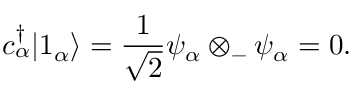<formula> <loc_0><loc_0><loc_500><loc_500>c _ { \alpha } ^ { \dagger } | 1 _ { \alpha } \rangle = { \frac { 1 } { \sqrt { 2 } } } \psi _ { \alpha } \otimes _ { - } \psi _ { \alpha } = 0 .</formula> 